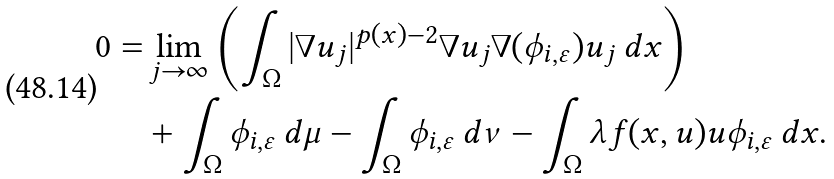Convert formula to latex. <formula><loc_0><loc_0><loc_500><loc_500>0 = & \lim _ { j \to \infty } \left ( \int _ { \Omega } | \nabla u _ { j } | ^ { p ( x ) - 2 } \nabla u _ { j } \nabla ( \phi _ { i , \varepsilon } ) u _ { j } \, d x \right ) \\ & + \int _ { \Omega } \phi _ { i , \varepsilon } \, d \mu - \int _ { \Omega } \phi _ { i , \varepsilon } \, d \nu - \int _ { \Omega } \lambda f ( x , u ) u \phi _ { i , \varepsilon } \, d x .</formula> 